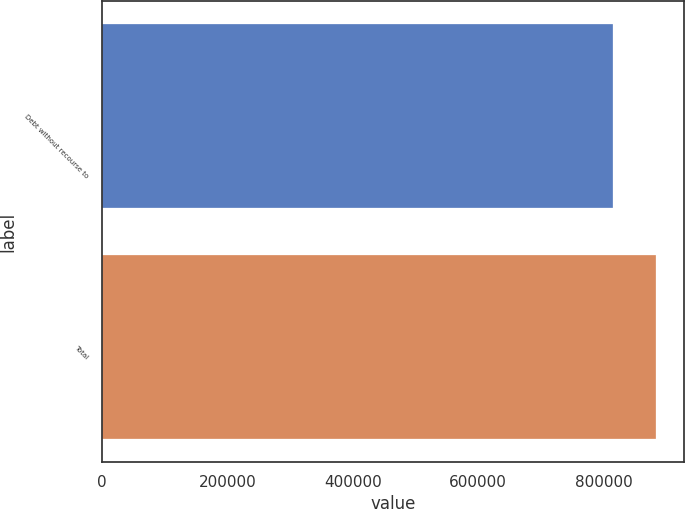Convert chart. <chart><loc_0><loc_0><loc_500><loc_500><bar_chart><fcel>Debt without recourse to<fcel>Total<nl><fcel>815481<fcel>883718<nl></chart> 